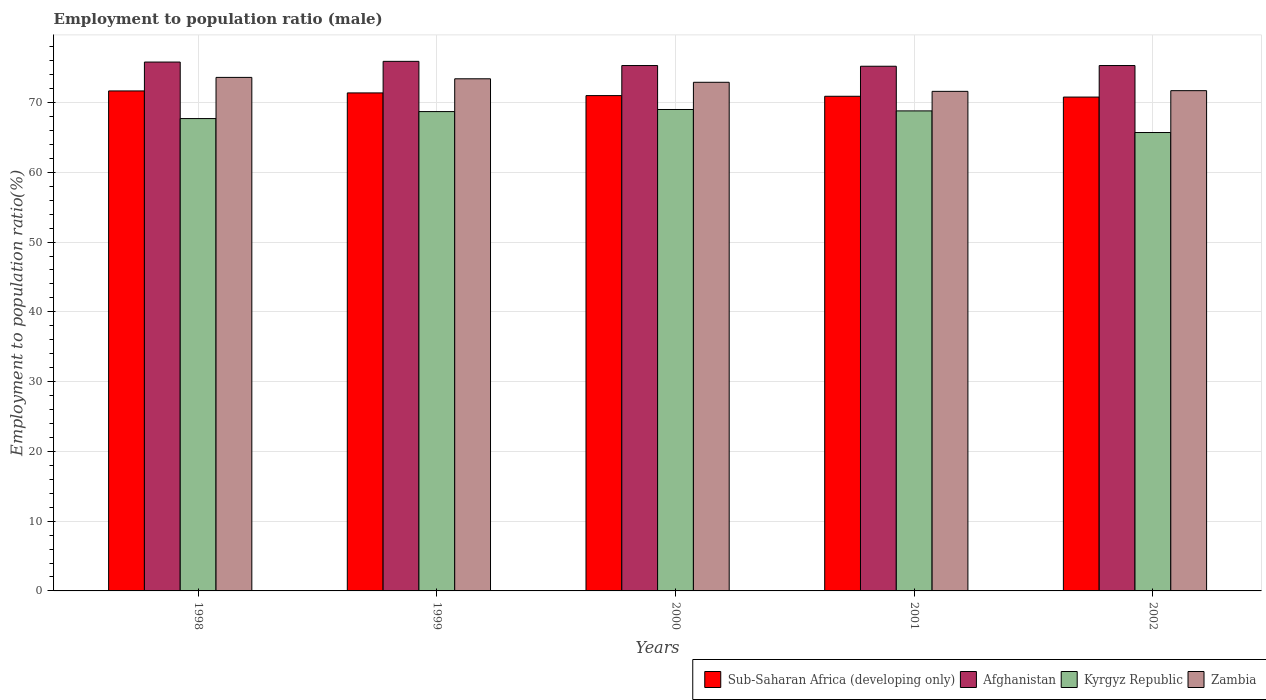How many different coloured bars are there?
Ensure brevity in your answer.  4. Are the number of bars on each tick of the X-axis equal?
Provide a succinct answer. Yes. How many bars are there on the 3rd tick from the left?
Keep it short and to the point. 4. How many bars are there on the 4th tick from the right?
Your response must be concise. 4. What is the employment to population ratio in Zambia in 2000?
Keep it short and to the point. 72.9. Across all years, what is the maximum employment to population ratio in Afghanistan?
Provide a succinct answer. 75.9. Across all years, what is the minimum employment to population ratio in Kyrgyz Republic?
Keep it short and to the point. 65.7. In which year was the employment to population ratio in Zambia minimum?
Offer a terse response. 2001. What is the total employment to population ratio in Afghanistan in the graph?
Your answer should be very brief. 377.5. What is the difference between the employment to population ratio in Kyrgyz Republic in 1998 and that in 2000?
Give a very brief answer. -1.3. What is the difference between the employment to population ratio in Afghanistan in 2000 and the employment to population ratio in Zambia in 1998?
Make the answer very short. 1.7. What is the average employment to population ratio in Sub-Saharan Africa (developing only) per year?
Your response must be concise. 71.14. In the year 2001, what is the difference between the employment to population ratio in Zambia and employment to population ratio in Kyrgyz Republic?
Make the answer very short. 2.8. In how many years, is the employment to population ratio in Zambia greater than 10 %?
Provide a succinct answer. 5. What is the ratio of the employment to population ratio in Zambia in 2000 to that in 2002?
Your response must be concise. 1.02. What is the difference between the highest and the second highest employment to population ratio in Afghanistan?
Your answer should be compact. 0.1. What is the difference between the highest and the lowest employment to population ratio in Sub-Saharan Africa (developing only)?
Provide a succinct answer. 0.88. In how many years, is the employment to population ratio in Zambia greater than the average employment to population ratio in Zambia taken over all years?
Provide a succinct answer. 3. Is the sum of the employment to population ratio in Zambia in 2001 and 2002 greater than the maximum employment to population ratio in Afghanistan across all years?
Offer a very short reply. Yes. What does the 3rd bar from the left in 2002 represents?
Ensure brevity in your answer.  Kyrgyz Republic. What does the 1st bar from the right in 1999 represents?
Provide a succinct answer. Zambia. How many bars are there?
Offer a very short reply. 20. How many years are there in the graph?
Give a very brief answer. 5. Does the graph contain grids?
Offer a terse response. Yes. Where does the legend appear in the graph?
Your answer should be compact. Bottom right. How many legend labels are there?
Your answer should be very brief. 4. How are the legend labels stacked?
Your response must be concise. Horizontal. What is the title of the graph?
Your answer should be compact. Employment to population ratio (male). Does "Switzerland" appear as one of the legend labels in the graph?
Your answer should be very brief. No. What is the label or title of the X-axis?
Make the answer very short. Years. What is the label or title of the Y-axis?
Keep it short and to the point. Employment to population ratio(%). What is the Employment to population ratio(%) in Sub-Saharan Africa (developing only) in 1998?
Give a very brief answer. 71.66. What is the Employment to population ratio(%) of Afghanistan in 1998?
Provide a succinct answer. 75.8. What is the Employment to population ratio(%) in Kyrgyz Republic in 1998?
Your answer should be very brief. 67.7. What is the Employment to population ratio(%) of Zambia in 1998?
Offer a very short reply. 73.6. What is the Employment to population ratio(%) of Sub-Saharan Africa (developing only) in 1999?
Provide a succinct answer. 71.38. What is the Employment to population ratio(%) in Afghanistan in 1999?
Ensure brevity in your answer.  75.9. What is the Employment to population ratio(%) of Kyrgyz Republic in 1999?
Give a very brief answer. 68.7. What is the Employment to population ratio(%) of Zambia in 1999?
Provide a short and direct response. 73.4. What is the Employment to population ratio(%) in Sub-Saharan Africa (developing only) in 2000?
Ensure brevity in your answer.  70.99. What is the Employment to population ratio(%) of Afghanistan in 2000?
Offer a terse response. 75.3. What is the Employment to population ratio(%) in Zambia in 2000?
Your answer should be very brief. 72.9. What is the Employment to population ratio(%) in Sub-Saharan Africa (developing only) in 2001?
Make the answer very short. 70.89. What is the Employment to population ratio(%) of Afghanistan in 2001?
Your response must be concise. 75.2. What is the Employment to population ratio(%) in Kyrgyz Republic in 2001?
Your answer should be compact. 68.8. What is the Employment to population ratio(%) of Zambia in 2001?
Keep it short and to the point. 71.6. What is the Employment to population ratio(%) of Sub-Saharan Africa (developing only) in 2002?
Your response must be concise. 70.78. What is the Employment to population ratio(%) in Afghanistan in 2002?
Give a very brief answer. 75.3. What is the Employment to population ratio(%) in Kyrgyz Republic in 2002?
Keep it short and to the point. 65.7. What is the Employment to population ratio(%) in Zambia in 2002?
Give a very brief answer. 71.7. Across all years, what is the maximum Employment to population ratio(%) in Sub-Saharan Africa (developing only)?
Make the answer very short. 71.66. Across all years, what is the maximum Employment to population ratio(%) of Afghanistan?
Keep it short and to the point. 75.9. Across all years, what is the maximum Employment to population ratio(%) in Kyrgyz Republic?
Offer a very short reply. 69. Across all years, what is the maximum Employment to population ratio(%) in Zambia?
Make the answer very short. 73.6. Across all years, what is the minimum Employment to population ratio(%) of Sub-Saharan Africa (developing only)?
Offer a terse response. 70.78. Across all years, what is the minimum Employment to population ratio(%) in Afghanistan?
Keep it short and to the point. 75.2. Across all years, what is the minimum Employment to population ratio(%) in Kyrgyz Republic?
Give a very brief answer. 65.7. Across all years, what is the minimum Employment to population ratio(%) of Zambia?
Your response must be concise. 71.6. What is the total Employment to population ratio(%) in Sub-Saharan Africa (developing only) in the graph?
Ensure brevity in your answer.  355.71. What is the total Employment to population ratio(%) in Afghanistan in the graph?
Provide a short and direct response. 377.5. What is the total Employment to population ratio(%) in Kyrgyz Republic in the graph?
Provide a succinct answer. 339.9. What is the total Employment to population ratio(%) of Zambia in the graph?
Your answer should be very brief. 363.2. What is the difference between the Employment to population ratio(%) of Sub-Saharan Africa (developing only) in 1998 and that in 1999?
Keep it short and to the point. 0.28. What is the difference between the Employment to population ratio(%) in Afghanistan in 1998 and that in 1999?
Offer a very short reply. -0.1. What is the difference between the Employment to population ratio(%) of Kyrgyz Republic in 1998 and that in 1999?
Provide a succinct answer. -1. What is the difference between the Employment to population ratio(%) in Zambia in 1998 and that in 1999?
Offer a very short reply. 0.2. What is the difference between the Employment to population ratio(%) of Sub-Saharan Africa (developing only) in 1998 and that in 2000?
Your answer should be compact. 0.67. What is the difference between the Employment to population ratio(%) in Afghanistan in 1998 and that in 2000?
Make the answer very short. 0.5. What is the difference between the Employment to population ratio(%) of Kyrgyz Republic in 1998 and that in 2000?
Provide a short and direct response. -1.3. What is the difference between the Employment to population ratio(%) of Zambia in 1998 and that in 2000?
Make the answer very short. 0.7. What is the difference between the Employment to population ratio(%) in Sub-Saharan Africa (developing only) in 1998 and that in 2001?
Your response must be concise. 0.77. What is the difference between the Employment to population ratio(%) of Afghanistan in 1998 and that in 2001?
Provide a short and direct response. 0.6. What is the difference between the Employment to population ratio(%) of Zambia in 1998 and that in 2001?
Keep it short and to the point. 2. What is the difference between the Employment to population ratio(%) in Sub-Saharan Africa (developing only) in 1998 and that in 2002?
Give a very brief answer. 0.88. What is the difference between the Employment to population ratio(%) of Afghanistan in 1998 and that in 2002?
Make the answer very short. 0.5. What is the difference between the Employment to population ratio(%) of Zambia in 1998 and that in 2002?
Your answer should be compact. 1.9. What is the difference between the Employment to population ratio(%) of Sub-Saharan Africa (developing only) in 1999 and that in 2000?
Provide a succinct answer. 0.38. What is the difference between the Employment to population ratio(%) of Afghanistan in 1999 and that in 2000?
Your response must be concise. 0.6. What is the difference between the Employment to population ratio(%) of Sub-Saharan Africa (developing only) in 1999 and that in 2001?
Provide a succinct answer. 0.48. What is the difference between the Employment to population ratio(%) in Sub-Saharan Africa (developing only) in 1999 and that in 2002?
Offer a very short reply. 0.59. What is the difference between the Employment to population ratio(%) in Afghanistan in 1999 and that in 2002?
Your answer should be very brief. 0.6. What is the difference between the Employment to population ratio(%) of Kyrgyz Republic in 1999 and that in 2002?
Make the answer very short. 3. What is the difference between the Employment to population ratio(%) of Zambia in 1999 and that in 2002?
Offer a very short reply. 1.7. What is the difference between the Employment to population ratio(%) in Sub-Saharan Africa (developing only) in 2000 and that in 2001?
Make the answer very short. 0.1. What is the difference between the Employment to population ratio(%) in Afghanistan in 2000 and that in 2001?
Provide a succinct answer. 0.1. What is the difference between the Employment to population ratio(%) in Zambia in 2000 and that in 2001?
Give a very brief answer. 1.3. What is the difference between the Employment to population ratio(%) in Sub-Saharan Africa (developing only) in 2000 and that in 2002?
Your answer should be very brief. 0.21. What is the difference between the Employment to population ratio(%) of Afghanistan in 2000 and that in 2002?
Your answer should be compact. 0. What is the difference between the Employment to population ratio(%) of Sub-Saharan Africa (developing only) in 2001 and that in 2002?
Provide a succinct answer. 0.11. What is the difference between the Employment to population ratio(%) of Kyrgyz Republic in 2001 and that in 2002?
Your answer should be compact. 3.1. What is the difference between the Employment to population ratio(%) of Sub-Saharan Africa (developing only) in 1998 and the Employment to population ratio(%) of Afghanistan in 1999?
Offer a terse response. -4.24. What is the difference between the Employment to population ratio(%) in Sub-Saharan Africa (developing only) in 1998 and the Employment to population ratio(%) in Kyrgyz Republic in 1999?
Your answer should be compact. 2.96. What is the difference between the Employment to population ratio(%) in Sub-Saharan Africa (developing only) in 1998 and the Employment to population ratio(%) in Zambia in 1999?
Provide a succinct answer. -1.74. What is the difference between the Employment to population ratio(%) of Afghanistan in 1998 and the Employment to population ratio(%) of Kyrgyz Republic in 1999?
Your response must be concise. 7.1. What is the difference between the Employment to population ratio(%) of Afghanistan in 1998 and the Employment to population ratio(%) of Zambia in 1999?
Give a very brief answer. 2.4. What is the difference between the Employment to population ratio(%) in Kyrgyz Republic in 1998 and the Employment to population ratio(%) in Zambia in 1999?
Your response must be concise. -5.7. What is the difference between the Employment to population ratio(%) in Sub-Saharan Africa (developing only) in 1998 and the Employment to population ratio(%) in Afghanistan in 2000?
Make the answer very short. -3.64. What is the difference between the Employment to population ratio(%) in Sub-Saharan Africa (developing only) in 1998 and the Employment to population ratio(%) in Kyrgyz Republic in 2000?
Provide a succinct answer. 2.66. What is the difference between the Employment to population ratio(%) of Sub-Saharan Africa (developing only) in 1998 and the Employment to population ratio(%) of Zambia in 2000?
Your answer should be very brief. -1.24. What is the difference between the Employment to population ratio(%) in Afghanistan in 1998 and the Employment to population ratio(%) in Kyrgyz Republic in 2000?
Provide a short and direct response. 6.8. What is the difference between the Employment to population ratio(%) of Afghanistan in 1998 and the Employment to population ratio(%) of Zambia in 2000?
Your response must be concise. 2.9. What is the difference between the Employment to population ratio(%) in Sub-Saharan Africa (developing only) in 1998 and the Employment to population ratio(%) in Afghanistan in 2001?
Ensure brevity in your answer.  -3.54. What is the difference between the Employment to population ratio(%) in Sub-Saharan Africa (developing only) in 1998 and the Employment to population ratio(%) in Kyrgyz Republic in 2001?
Offer a terse response. 2.86. What is the difference between the Employment to population ratio(%) in Sub-Saharan Africa (developing only) in 1998 and the Employment to population ratio(%) in Zambia in 2001?
Provide a short and direct response. 0.06. What is the difference between the Employment to population ratio(%) of Afghanistan in 1998 and the Employment to population ratio(%) of Kyrgyz Republic in 2001?
Make the answer very short. 7. What is the difference between the Employment to population ratio(%) of Sub-Saharan Africa (developing only) in 1998 and the Employment to population ratio(%) of Afghanistan in 2002?
Your response must be concise. -3.64. What is the difference between the Employment to population ratio(%) in Sub-Saharan Africa (developing only) in 1998 and the Employment to population ratio(%) in Kyrgyz Republic in 2002?
Provide a short and direct response. 5.96. What is the difference between the Employment to population ratio(%) in Sub-Saharan Africa (developing only) in 1998 and the Employment to population ratio(%) in Zambia in 2002?
Your answer should be very brief. -0.04. What is the difference between the Employment to population ratio(%) in Afghanistan in 1998 and the Employment to population ratio(%) in Kyrgyz Republic in 2002?
Offer a terse response. 10.1. What is the difference between the Employment to population ratio(%) of Afghanistan in 1998 and the Employment to population ratio(%) of Zambia in 2002?
Your answer should be compact. 4.1. What is the difference between the Employment to population ratio(%) in Kyrgyz Republic in 1998 and the Employment to population ratio(%) in Zambia in 2002?
Offer a very short reply. -4. What is the difference between the Employment to population ratio(%) in Sub-Saharan Africa (developing only) in 1999 and the Employment to population ratio(%) in Afghanistan in 2000?
Your response must be concise. -3.92. What is the difference between the Employment to population ratio(%) of Sub-Saharan Africa (developing only) in 1999 and the Employment to population ratio(%) of Kyrgyz Republic in 2000?
Your answer should be very brief. 2.38. What is the difference between the Employment to population ratio(%) in Sub-Saharan Africa (developing only) in 1999 and the Employment to population ratio(%) in Zambia in 2000?
Your answer should be very brief. -1.52. What is the difference between the Employment to population ratio(%) in Afghanistan in 1999 and the Employment to population ratio(%) in Kyrgyz Republic in 2000?
Make the answer very short. 6.9. What is the difference between the Employment to population ratio(%) of Sub-Saharan Africa (developing only) in 1999 and the Employment to population ratio(%) of Afghanistan in 2001?
Offer a very short reply. -3.82. What is the difference between the Employment to population ratio(%) of Sub-Saharan Africa (developing only) in 1999 and the Employment to population ratio(%) of Kyrgyz Republic in 2001?
Offer a terse response. 2.58. What is the difference between the Employment to population ratio(%) of Sub-Saharan Africa (developing only) in 1999 and the Employment to population ratio(%) of Zambia in 2001?
Offer a terse response. -0.22. What is the difference between the Employment to population ratio(%) in Afghanistan in 1999 and the Employment to population ratio(%) in Zambia in 2001?
Make the answer very short. 4.3. What is the difference between the Employment to population ratio(%) of Kyrgyz Republic in 1999 and the Employment to population ratio(%) of Zambia in 2001?
Your answer should be very brief. -2.9. What is the difference between the Employment to population ratio(%) in Sub-Saharan Africa (developing only) in 1999 and the Employment to population ratio(%) in Afghanistan in 2002?
Offer a terse response. -3.92. What is the difference between the Employment to population ratio(%) in Sub-Saharan Africa (developing only) in 1999 and the Employment to population ratio(%) in Kyrgyz Republic in 2002?
Provide a short and direct response. 5.68. What is the difference between the Employment to population ratio(%) in Sub-Saharan Africa (developing only) in 1999 and the Employment to population ratio(%) in Zambia in 2002?
Provide a short and direct response. -0.32. What is the difference between the Employment to population ratio(%) in Afghanistan in 1999 and the Employment to population ratio(%) in Zambia in 2002?
Your response must be concise. 4.2. What is the difference between the Employment to population ratio(%) in Kyrgyz Republic in 1999 and the Employment to population ratio(%) in Zambia in 2002?
Offer a terse response. -3. What is the difference between the Employment to population ratio(%) of Sub-Saharan Africa (developing only) in 2000 and the Employment to population ratio(%) of Afghanistan in 2001?
Give a very brief answer. -4.21. What is the difference between the Employment to population ratio(%) in Sub-Saharan Africa (developing only) in 2000 and the Employment to population ratio(%) in Kyrgyz Republic in 2001?
Ensure brevity in your answer.  2.19. What is the difference between the Employment to population ratio(%) of Sub-Saharan Africa (developing only) in 2000 and the Employment to population ratio(%) of Zambia in 2001?
Offer a very short reply. -0.61. What is the difference between the Employment to population ratio(%) of Sub-Saharan Africa (developing only) in 2000 and the Employment to population ratio(%) of Afghanistan in 2002?
Provide a succinct answer. -4.31. What is the difference between the Employment to population ratio(%) of Sub-Saharan Africa (developing only) in 2000 and the Employment to population ratio(%) of Kyrgyz Republic in 2002?
Offer a very short reply. 5.29. What is the difference between the Employment to population ratio(%) of Sub-Saharan Africa (developing only) in 2000 and the Employment to population ratio(%) of Zambia in 2002?
Ensure brevity in your answer.  -0.71. What is the difference between the Employment to population ratio(%) of Afghanistan in 2000 and the Employment to population ratio(%) of Kyrgyz Republic in 2002?
Offer a very short reply. 9.6. What is the difference between the Employment to population ratio(%) in Sub-Saharan Africa (developing only) in 2001 and the Employment to population ratio(%) in Afghanistan in 2002?
Your answer should be very brief. -4.41. What is the difference between the Employment to population ratio(%) in Sub-Saharan Africa (developing only) in 2001 and the Employment to population ratio(%) in Kyrgyz Republic in 2002?
Provide a succinct answer. 5.19. What is the difference between the Employment to population ratio(%) of Sub-Saharan Africa (developing only) in 2001 and the Employment to population ratio(%) of Zambia in 2002?
Your answer should be compact. -0.81. What is the difference between the Employment to population ratio(%) in Afghanistan in 2001 and the Employment to population ratio(%) in Kyrgyz Republic in 2002?
Your answer should be very brief. 9.5. What is the difference between the Employment to population ratio(%) of Kyrgyz Republic in 2001 and the Employment to population ratio(%) of Zambia in 2002?
Provide a short and direct response. -2.9. What is the average Employment to population ratio(%) of Sub-Saharan Africa (developing only) per year?
Your answer should be very brief. 71.14. What is the average Employment to population ratio(%) in Afghanistan per year?
Keep it short and to the point. 75.5. What is the average Employment to population ratio(%) of Kyrgyz Republic per year?
Give a very brief answer. 67.98. What is the average Employment to population ratio(%) of Zambia per year?
Offer a terse response. 72.64. In the year 1998, what is the difference between the Employment to population ratio(%) of Sub-Saharan Africa (developing only) and Employment to population ratio(%) of Afghanistan?
Provide a succinct answer. -4.14. In the year 1998, what is the difference between the Employment to population ratio(%) in Sub-Saharan Africa (developing only) and Employment to population ratio(%) in Kyrgyz Republic?
Your answer should be very brief. 3.96. In the year 1998, what is the difference between the Employment to population ratio(%) of Sub-Saharan Africa (developing only) and Employment to population ratio(%) of Zambia?
Provide a succinct answer. -1.94. In the year 1998, what is the difference between the Employment to population ratio(%) in Afghanistan and Employment to population ratio(%) in Kyrgyz Republic?
Ensure brevity in your answer.  8.1. In the year 1998, what is the difference between the Employment to population ratio(%) in Afghanistan and Employment to population ratio(%) in Zambia?
Your answer should be very brief. 2.2. In the year 1999, what is the difference between the Employment to population ratio(%) in Sub-Saharan Africa (developing only) and Employment to population ratio(%) in Afghanistan?
Your answer should be very brief. -4.52. In the year 1999, what is the difference between the Employment to population ratio(%) of Sub-Saharan Africa (developing only) and Employment to population ratio(%) of Kyrgyz Republic?
Ensure brevity in your answer.  2.68. In the year 1999, what is the difference between the Employment to population ratio(%) of Sub-Saharan Africa (developing only) and Employment to population ratio(%) of Zambia?
Your answer should be compact. -2.02. In the year 1999, what is the difference between the Employment to population ratio(%) in Afghanistan and Employment to population ratio(%) in Kyrgyz Republic?
Provide a succinct answer. 7.2. In the year 1999, what is the difference between the Employment to population ratio(%) in Afghanistan and Employment to population ratio(%) in Zambia?
Make the answer very short. 2.5. In the year 2000, what is the difference between the Employment to population ratio(%) of Sub-Saharan Africa (developing only) and Employment to population ratio(%) of Afghanistan?
Ensure brevity in your answer.  -4.31. In the year 2000, what is the difference between the Employment to population ratio(%) of Sub-Saharan Africa (developing only) and Employment to population ratio(%) of Kyrgyz Republic?
Offer a terse response. 1.99. In the year 2000, what is the difference between the Employment to population ratio(%) in Sub-Saharan Africa (developing only) and Employment to population ratio(%) in Zambia?
Offer a very short reply. -1.91. In the year 2000, what is the difference between the Employment to population ratio(%) in Afghanistan and Employment to population ratio(%) in Zambia?
Make the answer very short. 2.4. In the year 2000, what is the difference between the Employment to population ratio(%) of Kyrgyz Republic and Employment to population ratio(%) of Zambia?
Your answer should be compact. -3.9. In the year 2001, what is the difference between the Employment to population ratio(%) in Sub-Saharan Africa (developing only) and Employment to population ratio(%) in Afghanistan?
Offer a terse response. -4.31. In the year 2001, what is the difference between the Employment to population ratio(%) of Sub-Saharan Africa (developing only) and Employment to population ratio(%) of Kyrgyz Republic?
Your answer should be compact. 2.09. In the year 2001, what is the difference between the Employment to population ratio(%) in Sub-Saharan Africa (developing only) and Employment to population ratio(%) in Zambia?
Make the answer very short. -0.71. In the year 2001, what is the difference between the Employment to population ratio(%) of Afghanistan and Employment to population ratio(%) of Kyrgyz Republic?
Offer a terse response. 6.4. In the year 2002, what is the difference between the Employment to population ratio(%) of Sub-Saharan Africa (developing only) and Employment to population ratio(%) of Afghanistan?
Your answer should be compact. -4.52. In the year 2002, what is the difference between the Employment to population ratio(%) in Sub-Saharan Africa (developing only) and Employment to population ratio(%) in Kyrgyz Republic?
Make the answer very short. 5.08. In the year 2002, what is the difference between the Employment to population ratio(%) in Sub-Saharan Africa (developing only) and Employment to population ratio(%) in Zambia?
Your answer should be very brief. -0.92. What is the ratio of the Employment to population ratio(%) in Sub-Saharan Africa (developing only) in 1998 to that in 1999?
Offer a terse response. 1. What is the ratio of the Employment to population ratio(%) in Afghanistan in 1998 to that in 1999?
Offer a very short reply. 1. What is the ratio of the Employment to population ratio(%) in Kyrgyz Republic in 1998 to that in 1999?
Keep it short and to the point. 0.99. What is the ratio of the Employment to population ratio(%) in Zambia in 1998 to that in 1999?
Keep it short and to the point. 1. What is the ratio of the Employment to population ratio(%) in Sub-Saharan Africa (developing only) in 1998 to that in 2000?
Offer a terse response. 1.01. What is the ratio of the Employment to population ratio(%) in Afghanistan in 1998 to that in 2000?
Make the answer very short. 1.01. What is the ratio of the Employment to population ratio(%) of Kyrgyz Republic in 1998 to that in 2000?
Your answer should be compact. 0.98. What is the ratio of the Employment to population ratio(%) in Zambia in 1998 to that in 2000?
Offer a terse response. 1.01. What is the ratio of the Employment to population ratio(%) of Sub-Saharan Africa (developing only) in 1998 to that in 2001?
Keep it short and to the point. 1.01. What is the ratio of the Employment to population ratio(%) in Afghanistan in 1998 to that in 2001?
Offer a terse response. 1.01. What is the ratio of the Employment to population ratio(%) in Zambia in 1998 to that in 2001?
Offer a very short reply. 1.03. What is the ratio of the Employment to population ratio(%) of Sub-Saharan Africa (developing only) in 1998 to that in 2002?
Your answer should be compact. 1.01. What is the ratio of the Employment to population ratio(%) of Afghanistan in 1998 to that in 2002?
Your answer should be compact. 1.01. What is the ratio of the Employment to population ratio(%) in Kyrgyz Republic in 1998 to that in 2002?
Make the answer very short. 1.03. What is the ratio of the Employment to population ratio(%) in Zambia in 1998 to that in 2002?
Provide a short and direct response. 1.03. What is the ratio of the Employment to population ratio(%) of Sub-Saharan Africa (developing only) in 1999 to that in 2000?
Your response must be concise. 1.01. What is the ratio of the Employment to population ratio(%) of Sub-Saharan Africa (developing only) in 1999 to that in 2001?
Your answer should be very brief. 1.01. What is the ratio of the Employment to population ratio(%) in Afghanistan in 1999 to that in 2001?
Your answer should be compact. 1.01. What is the ratio of the Employment to population ratio(%) of Zambia in 1999 to that in 2001?
Give a very brief answer. 1.03. What is the ratio of the Employment to population ratio(%) in Sub-Saharan Africa (developing only) in 1999 to that in 2002?
Make the answer very short. 1.01. What is the ratio of the Employment to population ratio(%) in Kyrgyz Republic in 1999 to that in 2002?
Make the answer very short. 1.05. What is the ratio of the Employment to population ratio(%) in Zambia in 1999 to that in 2002?
Provide a succinct answer. 1.02. What is the ratio of the Employment to population ratio(%) of Sub-Saharan Africa (developing only) in 2000 to that in 2001?
Offer a very short reply. 1. What is the ratio of the Employment to population ratio(%) of Zambia in 2000 to that in 2001?
Keep it short and to the point. 1.02. What is the ratio of the Employment to population ratio(%) of Sub-Saharan Africa (developing only) in 2000 to that in 2002?
Keep it short and to the point. 1. What is the ratio of the Employment to population ratio(%) of Afghanistan in 2000 to that in 2002?
Provide a short and direct response. 1. What is the ratio of the Employment to population ratio(%) in Kyrgyz Republic in 2000 to that in 2002?
Your answer should be compact. 1.05. What is the ratio of the Employment to population ratio(%) of Zambia in 2000 to that in 2002?
Your answer should be very brief. 1.02. What is the ratio of the Employment to population ratio(%) in Kyrgyz Republic in 2001 to that in 2002?
Give a very brief answer. 1.05. What is the ratio of the Employment to population ratio(%) of Zambia in 2001 to that in 2002?
Provide a succinct answer. 1. What is the difference between the highest and the second highest Employment to population ratio(%) of Sub-Saharan Africa (developing only)?
Make the answer very short. 0.28. What is the difference between the highest and the second highest Employment to population ratio(%) of Afghanistan?
Provide a short and direct response. 0.1. What is the difference between the highest and the second highest Employment to population ratio(%) of Kyrgyz Republic?
Your answer should be very brief. 0.2. What is the difference between the highest and the second highest Employment to population ratio(%) in Zambia?
Your response must be concise. 0.2. What is the difference between the highest and the lowest Employment to population ratio(%) in Sub-Saharan Africa (developing only)?
Keep it short and to the point. 0.88. What is the difference between the highest and the lowest Employment to population ratio(%) of Afghanistan?
Your answer should be very brief. 0.7. 